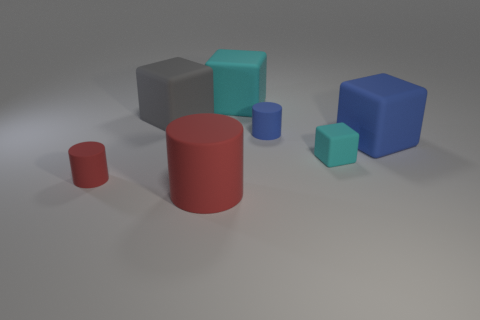There is a rubber object that is the same color as the tiny block; what shape is it?
Offer a terse response. Cube. What is the shape of the large rubber object that is both in front of the small blue matte thing and to the left of the blue matte cube?
Offer a very short reply. Cylinder. There is a small red object that is made of the same material as the big blue block; what is its shape?
Make the answer very short. Cylinder. There is a cyan cube that is in front of the large cyan block; what is it made of?
Your response must be concise. Rubber. Does the object behind the gray thing have the same size as the red matte thing that is right of the tiny red cylinder?
Keep it short and to the point. Yes. What is the color of the tiny rubber cube?
Make the answer very short. Cyan. Does the matte thing in front of the small red matte object have the same shape as the small cyan matte object?
Offer a terse response. No. There is a gray matte object that is the same size as the blue rubber block; what shape is it?
Your answer should be very brief. Cube. Is there a small thing that has the same color as the big rubber cylinder?
Provide a short and direct response. Yes. Does the large matte cylinder have the same color as the tiny rubber thing that is in front of the tiny rubber cube?
Provide a short and direct response. Yes. 